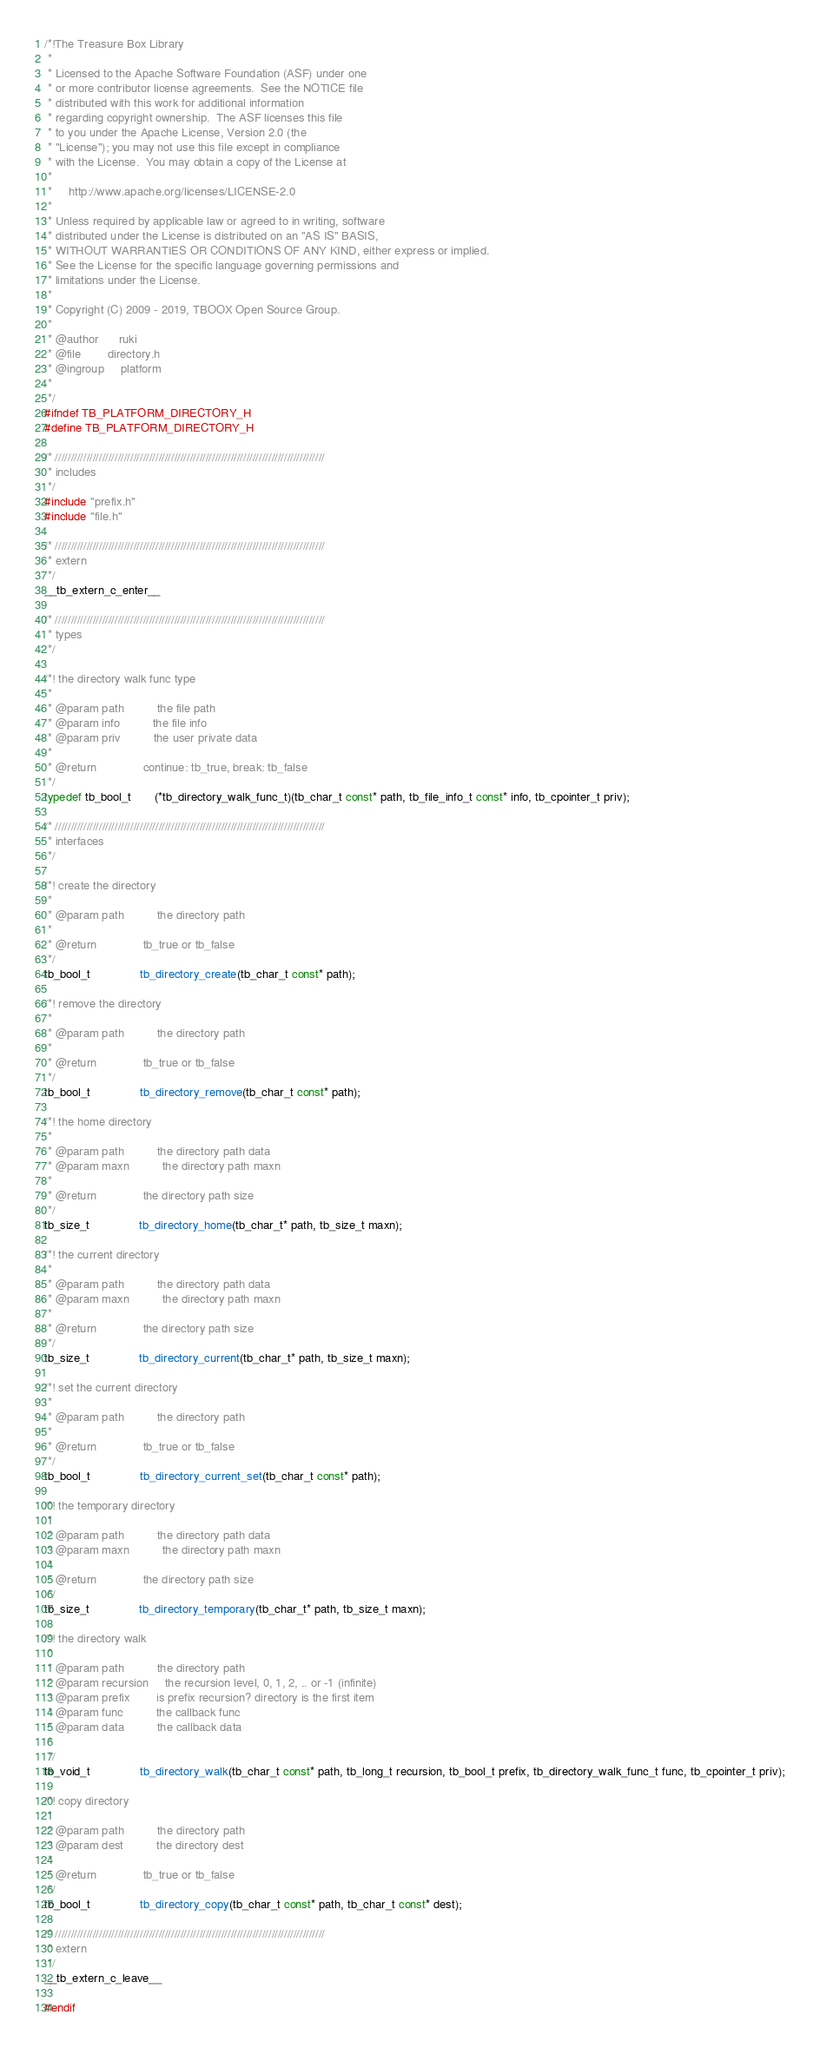<code> <loc_0><loc_0><loc_500><loc_500><_C_>/*!The Treasure Box Library
 *
 * Licensed to the Apache Software Foundation (ASF) under one
 * or more contributor license agreements.  See the NOTICE file
 * distributed with this work for additional information
 * regarding copyright ownership.  The ASF licenses this file
 * to you under the Apache License, Version 2.0 (the
 * "License"); you may not use this file except in compliance
 * with the License.  You may obtain a copy of the License at
 *
 *     http://www.apache.org/licenses/LICENSE-2.0
 *
 * Unless required by applicable law or agreed to in writing, software
 * distributed under the License is distributed on an "AS IS" BASIS,
 * WITHOUT WARRANTIES OR CONDITIONS OF ANY KIND, either express or implied.
 * See the License for the specific language governing permissions and
 * limitations under the License.
 * 
 * Copyright (C) 2009 - 2019, TBOOX Open Source Group.
 *
 * @author      ruki
 * @file        directory.h
 * @ingroup     platform
 *
 */
#ifndef TB_PLATFORM_DIRECTORY_H
#define TB_PLATFORM_DIRECTORY_H

/* //////////////////////////////////////////////////////////////////////////////////////
 * includes
 */
#include "prefix.h"
#include "file.h"

/* //////////////////////////////////////////////////////////////////////////////////////
 * extern
 */
__tb_extern_c_enter__

/* //////////////////////////////////////////////////////////////////////////////////////
 * types
 */

/*! the directory walk func type
 *
 * @param path          the file path
 * @param info          the file info
 * @param priv          the user private data
 *
 * @return              continue: tb_true, break: tb_false
 */
typedef tb_bool_t       (*tb_directory_walk_func_t)(tb_char_t const* path, tb_file_info_t const* info, tb_cpointer_t priv);

/* //////////////////////////////////////////////////////////////////////////////////////
 * interfaces
 */

/*! create the directory
 * 
 * @param path          the directory path
 *
 * @return              tb_true or tb_false
 */
tb_bool_t               tb_directory_create(tb_char_t const* path);

/*! remove the directory
 * 
 * @param path          the directory path
 *
 * @return              tb_true or tb_false
 */
tb_bool_t               tb_directory_remove(tb_char_t const* path);

/*! the home directory
 * 
 * @param path          the directory path data
 * @param maxn          the directory path maxn
 *
 * @return              the directory path size
 */
tb_size_t               tb_directory_home(tb_char_t* path, tb_size_t maxn);

/*! the current directory
 * 
 * @param path          the directory path data
 * @param maxn          the directory path maxn
 *
 * @return              the directory path size
 */
tb_size_t               tb_directory_current(tb_char_t* path, tb_size_t maxn);

/*! set the current directory
 * 
 * @param path          the directory path 
 *
 * @return              tb_true or tb_false
 */
tb_bool_t               tb_directory_current_set(tb_char_t const* path);

/*! the temporary directory
 * 
 * @param path          the directory path data
 * @param maxn          the directory path maxn
 *
 * @return              the directory path size
 */
tb_size_t               tb_directory_temporary(tb_char_t* path, tb_size_t maxn);

/*! the directory walk
 *
 * @param path          the directory path
 * @param recursion     the recursion level, 0, 1, 2, .. or -1 (infinite)
 * @param prefix        is prefix recursion? directory is the first item
 * @param func          the callback func
 * @param data          the callback data
 * 
 */
tb_void_t               tb_directory_walk(tb_char_t const* path, tb_long_t recursion, tb_bool_t prefix, tb_directory_walk_func_t func, tb_cpointer_t priv);

/*! copy directory
 * 
 * @param path          the directory path
 * @param dest          the directory dest
 *
 * @return              tb_true or tb_false
 */
tb_bool_t               tb_directory_copy(tb_char_t const* path, tb_char_t const* dest);

/* //////////////////////////////////////////////////////////////////////////////////////
 * extern
 */
__tb_extern_c_leave__

#endif
</code> 